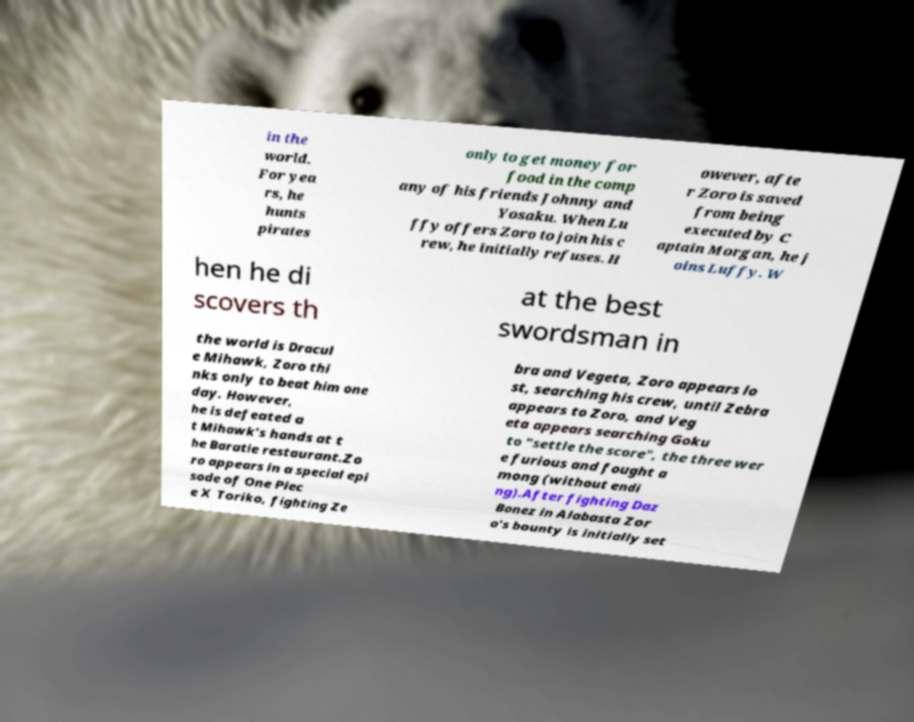I need the written content from this picture converted into text. Can you do that? in the world. For yea rs, he hunts pirates only to get money for food in the comp any of his friends Johnny and Yosaku. When Lu ffy offers Zoro to join his c rew, he initially refuses. H owever, afte r Zoro is saved from being executed by C aptain Morgan, he j oins Luffy. W hen he di scovers th at the best swordsman in the world is Dracul e Mihawk, Zoro thi nks only to beat him one day. However, he is defeated a t Mihawk's hands at t he Baratie restaurant.Zo ro appears in a special epi sode of One Piec e X Toriko, fighting Ze bra and Vegeta, Zoro appears lo st, searching his crew, until Zebra appears to Zoro, and Veg eta appears searching Goku to "settle the score", the three wer e furious and fought a mong (without endi ng).After fighting Daz Bonez in Alabasta Zor o's bounty is initially set 